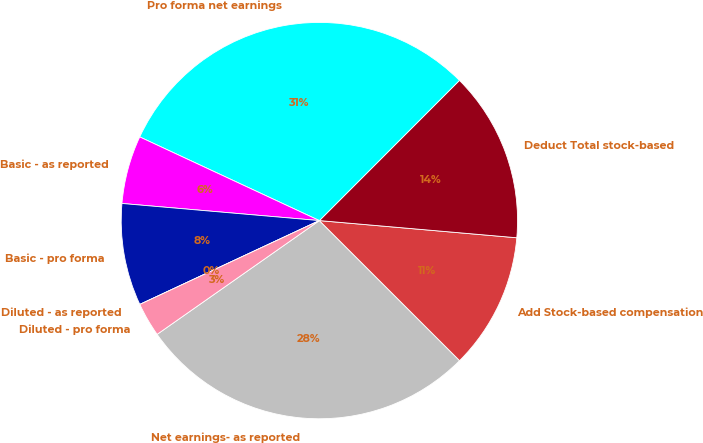Convert chart to OTSL. <chart><loc_0><loc_0><loc_500><loc_500><pie_chart><fcel>Net earnings- as reported<fcel>Add Stock-based compensation<fcel>Deduct Total stock-based<fcel>Pro forma net earnings<fcel>Basic - as reported<fcel>Basic - pro forma<fcel>Diluted - as reported<fcel>Diluted - pro forma<nl><fcel>27.78%<fcel>11.11%<fcel>13.89%<fcel>30.56%<fcel>5.56%<fcel>8.33%<fcel>0.0%<fcel>2.78%<nl></chart> 